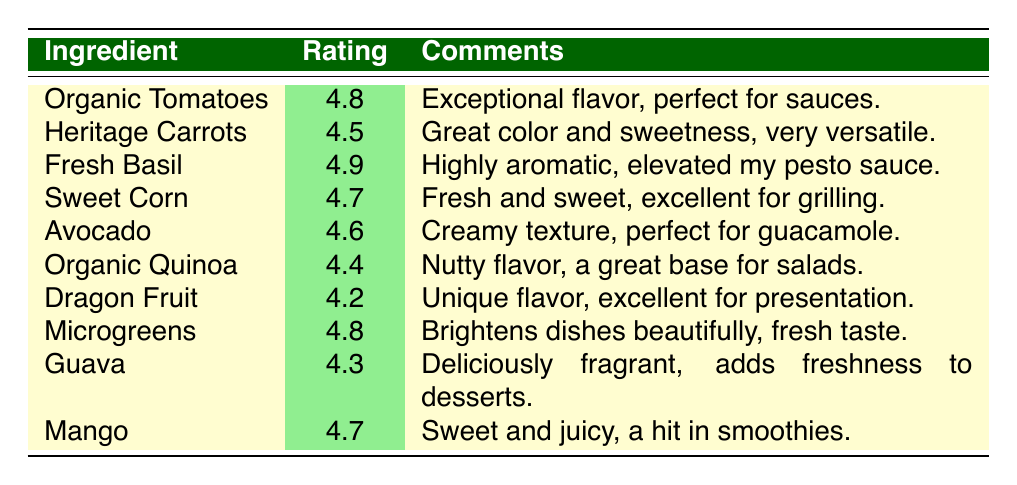What is the highest rating among the ingredients? The highest rating in the table is identified by looking through the ratings listed for each ingredient. The ratings range from 4.2 to 4.9, and 4.9 is the highest rating. The ingredient associated with this rating is Fresh Basil.
Answer: 4.9 Which ingredient has the lowest rating? The lowest rating in the table can be determined by scanning through the rating values. The ratings are: 4.8, 4.5, 4.9, 4.7, 4.6, 4.4, 4.2, 4.8, 4.3, and 4.7. The lowest rating is 4.2, which corresponds to the ingredient Dragon Fruit.
Answer: Dragon Fruit Is there an ingredient rated above 4.5? To answer this, we review the rating column and check which ratings exceed 4.5. The ratings 4.8, 4.9, 4.7, 4.6, and 4.8 all qualify. Since there are several such ingredients, the answer is yes.
Answer: Yes What is the average rating of all the ingredients? First, I need to add up all the ratings: 4.8 + 4.5 + 4.9 + 4.7 + 4.6 + 4.4 + 4.2 + 4.8 + 4.3 + 4.7 = 46.8. There are ten ingredients, so the average is calculated by dividing the total sum by the number of ingredients: 46.8 / 10 = 4.68.
Answer: 4.68 Which chef provided feedback on Sweet Corn? Looking through the table, we find the entry for Sweet Corn and identify the chef associated with that ingredient. The chef who rated Sweet Corn is Chef Thomas Rodriguez.
Answer: Chef Thomas Rodriguez Are all ingredients rated above 4.0? We can verify this by checking the ratings against the threshold of 4.0. Upon examining the ratings, all values (4.8, 4.5, 4.9, 4.7, 4.6, 4.4, 4.2, 4.8, 4.3, and 4.7) are indeed above 4.0. Therefore, the answer is yes.
Answer: Yes Which two ingredients have the same rating of 4.8? By scanning the rating column and noting all ingredients with 4.8 ratings, we find Organic Tomatoes and Microgreens both have a rating of 4.8.
Answer: Organic Tomatoes and Microgreens What is the median rating of the feedback? To find the median, we need to list the ratings in ascending order: 4.2, 4.3, 4.4, 4.5, 4.6, 4.7, 4.7, 4.8, 4.8, 4.9. With ten values present, the median is the average of the 5th and 6th values in this ordered list: (4.6 + 4.7) / 2 = 4.65.
Answer: 4.65 